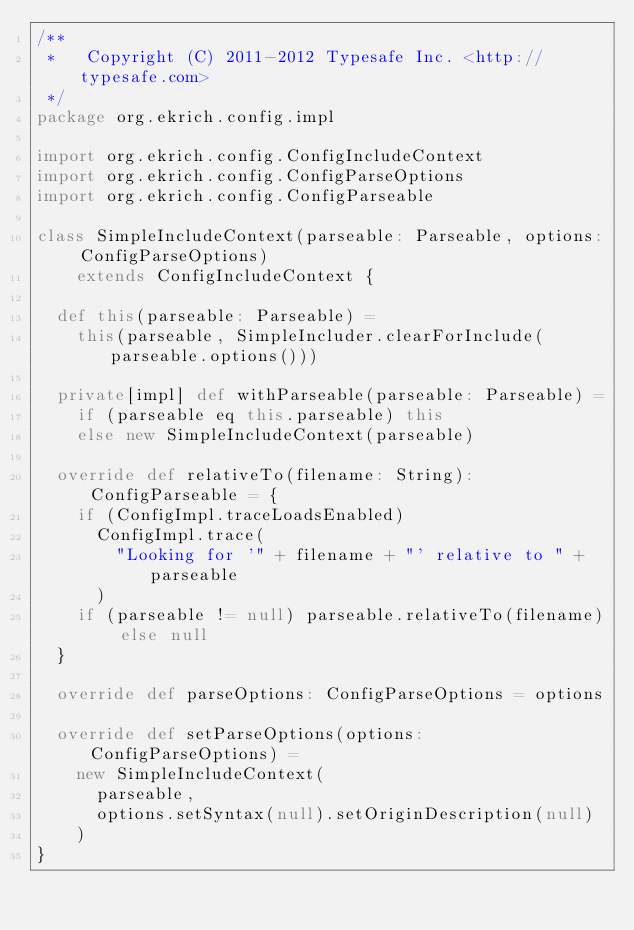Convert code to text. <code><loc_0><loc_0><loc_500><loc_500><_Scala_>/**
 *   Copyright (C) 2011-2012 Typesafe Inc. <http://typesafe.com>
 */
package org.ekrich.config.impl

import org.ekrich.config.ConfigIncludeContext
import org.ekrich.config.ConfigParseOptions
import org.ekrich.config.ConfigParseable

class SimpleIncludeContext(parseable: Parseable, options: ConfigParseOptions)
    extends ConfigIncludeContext {

  def this(parseable: Parseable) =
    this(parseable, SimpleIncluder.clearForInclude(parseable.options()))

  private[impl] def withParseable(parseable: Parseable) =
    if (parseable eq this.parseable) this
    else new SimpleIncludeContext(parseable)

  override def relativeTo(filename: String): ConfigParseable = {
    if (ConfigImpl.traceLoadsEnabled)
      ConfigImpl.trace(
        "Looking for '" + filename + "' relative to " + parseable
      )
    if (parseable != null) parseable.relativeTo(filename) else null
  }

  override def parseOptions: ConfigParseOptions = options

  override def setParseOptions(options: ConfigParseOptions) =
    new SimpleIncludeContext(
      parseable,
      options.setSyntax(null).setOriginDescription(null)
    )
}
</code> 